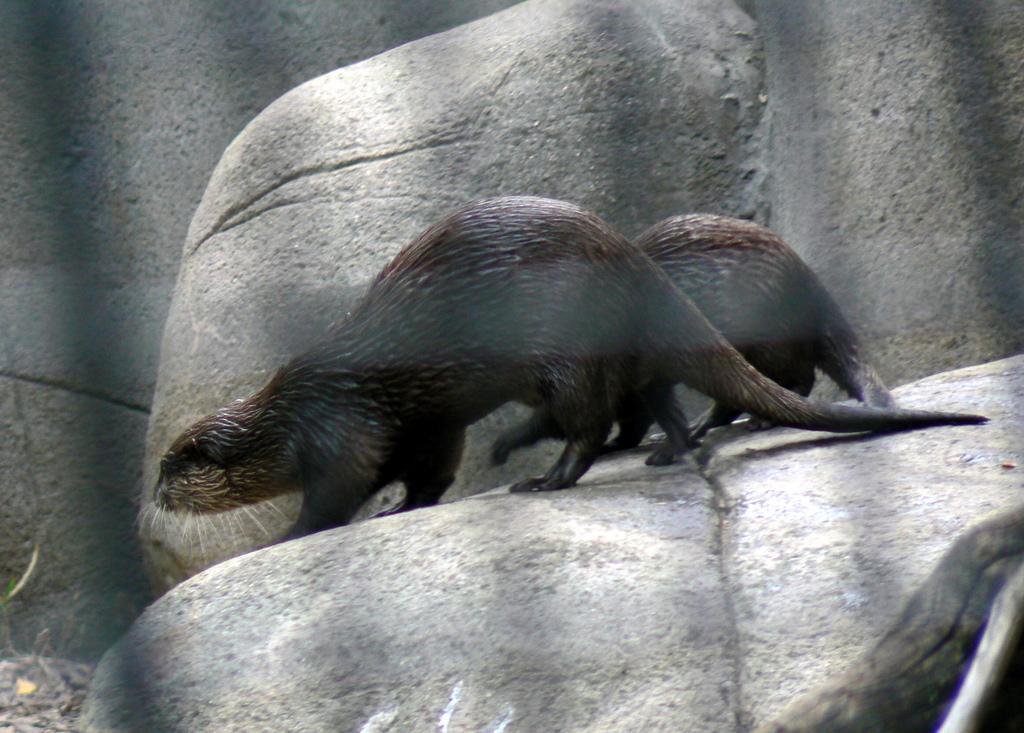Please provide a concise description of this image. In this image there are two animals standing on the rock as we can see in middle of this image and there are some rocks in the background. 